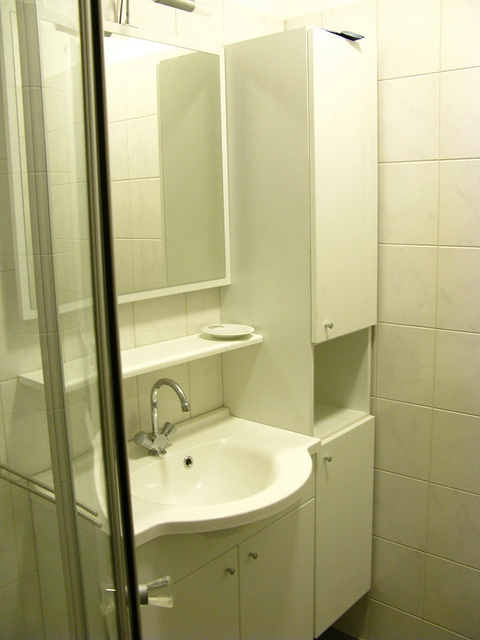Describe the objects in this image and their specific colors. I can see a sink in beige, tan, and olive tones in this image. 